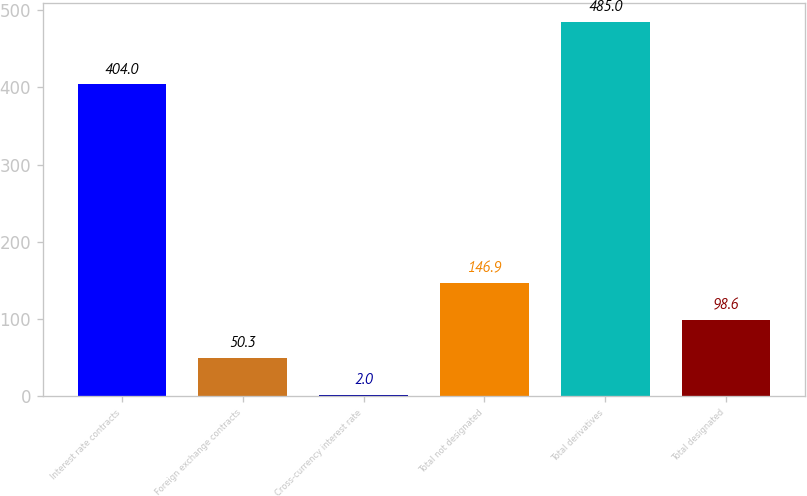Convert chart. <chart><loc_0><loc_0><loc_500><loc_500><bar_chart><fcel>Interest rate contracts<fcel>Foreign exchange contracts<fcel>Cross-currency interest rate<fcel>Total not designated<fcel>Total derivatives<fcel>Total designated<nl><fcel>404<fcel>50.3<fcel>2<fcel>146.9<fcel>485<fcel>98.6<nl></chart> 